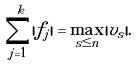Convert formula to latex. <formula><loc_0><loc_0><loc_500><loc_500>\sum _ { j = 1 } ^ { k } | f _ { j } | = \max _ { s \leq n } | v _ { s } | .</formula> 